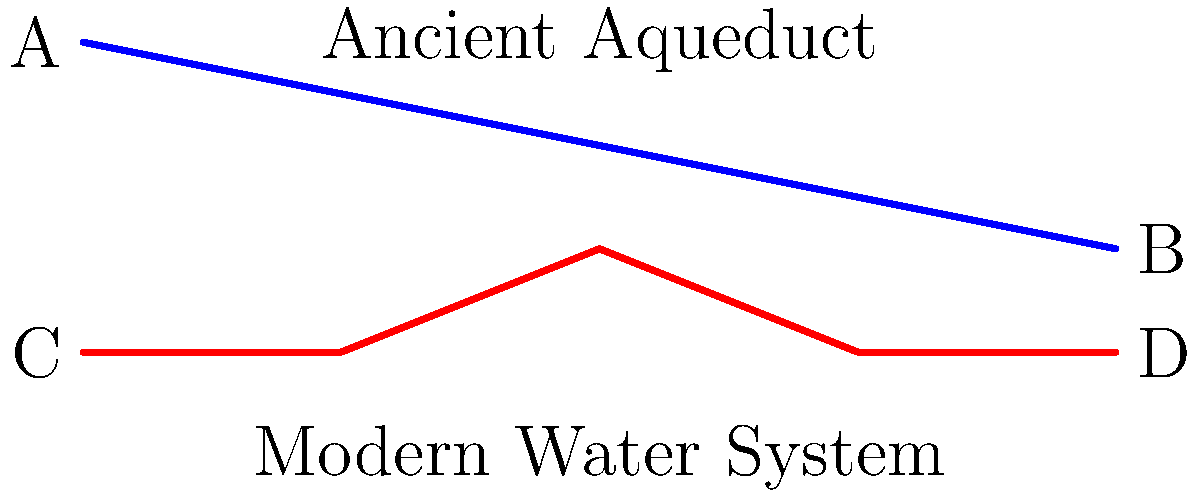Compare the simplified schematics of an ancient aqueduct (blue) and a modern water distribution system (red). Which system is more likely to maintain consistent water pressure throughout its length, and why? How might this difference impact the distribution of water to various socioeconomic groups in ancient and modern societies? To answer this question, let's analyze both systems step-by-step:

1. Ancient Aqueduct (Blue):
   - Relies on gravity for water flow
   - Has a continuous downward slope from point A to B
   - Water pressure decreases along the length due to friction and elevation loss

2. Modern Water System (Red):
   - Uses pumps and pressure regulators
   - Has varying elevations throughout its length
   - Can maintain relatively consistent pressure despite topographical changes

3. Pressure Consistency:
   - The modern system is more likely to maintain consistent water pressure
   - It can use pumps to boost pressure where needed
   - Pressure regulators can be installed to reduce excessive pressure

4. Impact on Water Distribution:
   - Ancient system:
     * Higher pressure at the beginning (point A)
     * Lower pressure at the end (point B)
     * Favors those living closer to the source or at higher elevations
   - Modern system:
     * More equal pressure distribution throughout (C to D)
     * Can serve a wider area with consistent pressure
     * Allows for more equitable water access across different locations

5. Socioeconomic Implications:
   - Ancient system:
     * May have led to social stratification based on water access
     * Elite residences often located near aqueduct sources or on hills
   - Modern system:
     * Enables more equal water distribution regardless of location
     * Potentially reduces water-related socioeconomic disparities

The modern water distribution system's ability to maintain consistent pressure throughout its length allows for more equitable water access across different socioeconomic groups and geographical locations.
Answer: Modern water system; allows more equitable distribution across socioeconomic groups due to consistent pressure maintenance. 